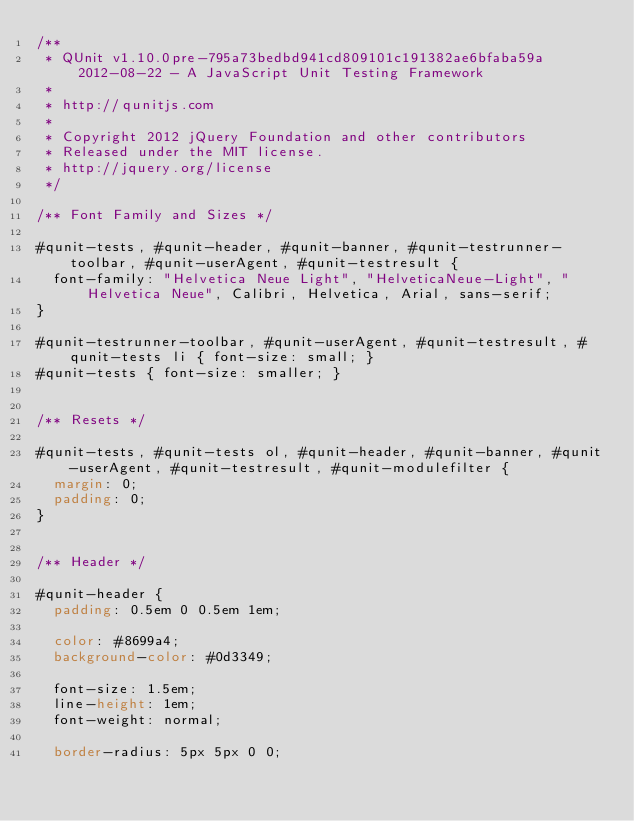Convert code to text. <code><loc_0><loc_0><loc_500><loc_500><_CSS_>/**
 * QUnit v1.10.0pre-795a73bedbd941cd809101c191382ae6bfaba59a 2012-08-22 - A JavaScript Unit Testing Framework
 *
 * http://qunitjs.com
 *
 * Copyright 2012 jQuery Foundation and other contributors
 * Released under the MIT license.
 * http://jquery.org/license
 */

/** Font Family and Sizes */

#qunit-tests, #qunit-header, #qunit-banner, #qunit-testrunner-toolbar, #qunit-userAgent, #qunit-testresult {
	font-family: "Helvetica Neue Light", "HelveticaNeue-Light", "Helvetica Neue", Calibri, Helvetica, Arial, sans-serif;
}

#qunit-testrunner-toolbar, #qunit-userAgent, #qunit-testresult, #qunit-tests li { font-size: small; }
#qunit-tests { font-size: smaller; }


/** Resets */

#qunit-tests, #qunit-tests ol, #qunit-header, #qunit-banner, #qunit-userAgent, #qunit-testresult, #qunit-modulefilter {
	margin: 0;
	padding: 0;
}


/** Header */

#qunit-header {
	padding: 0.5em 0 0.5em 1em;

	color: #8699a4;
	background-color: #0d3349;

	font-size: 1.5em;
	line-height: 1em;
	font-weight: normal;

	border-radius: 5px 5px 0 0;</code> 